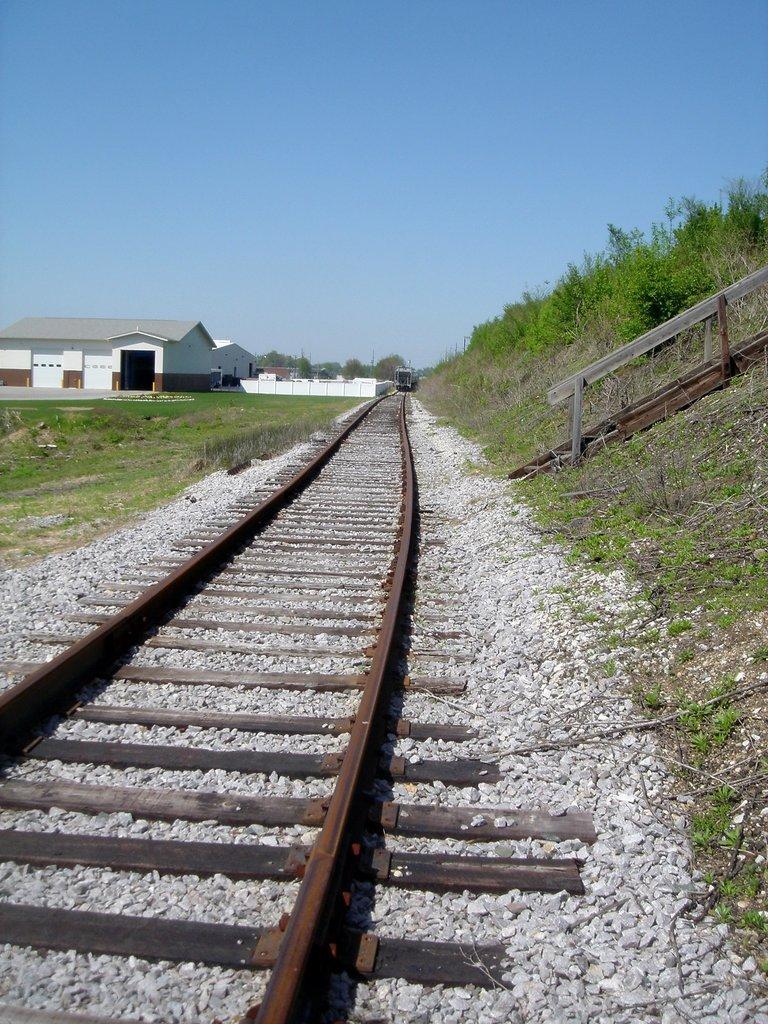Could you give a brief overview of what you see in this image? In this image in the front there is a railway track. On the right side there is grass on the ground and there is a wooden object and there are plants. On the left side there are houses, trees and there's grass on the ground and in the front there are stones on the ground. 